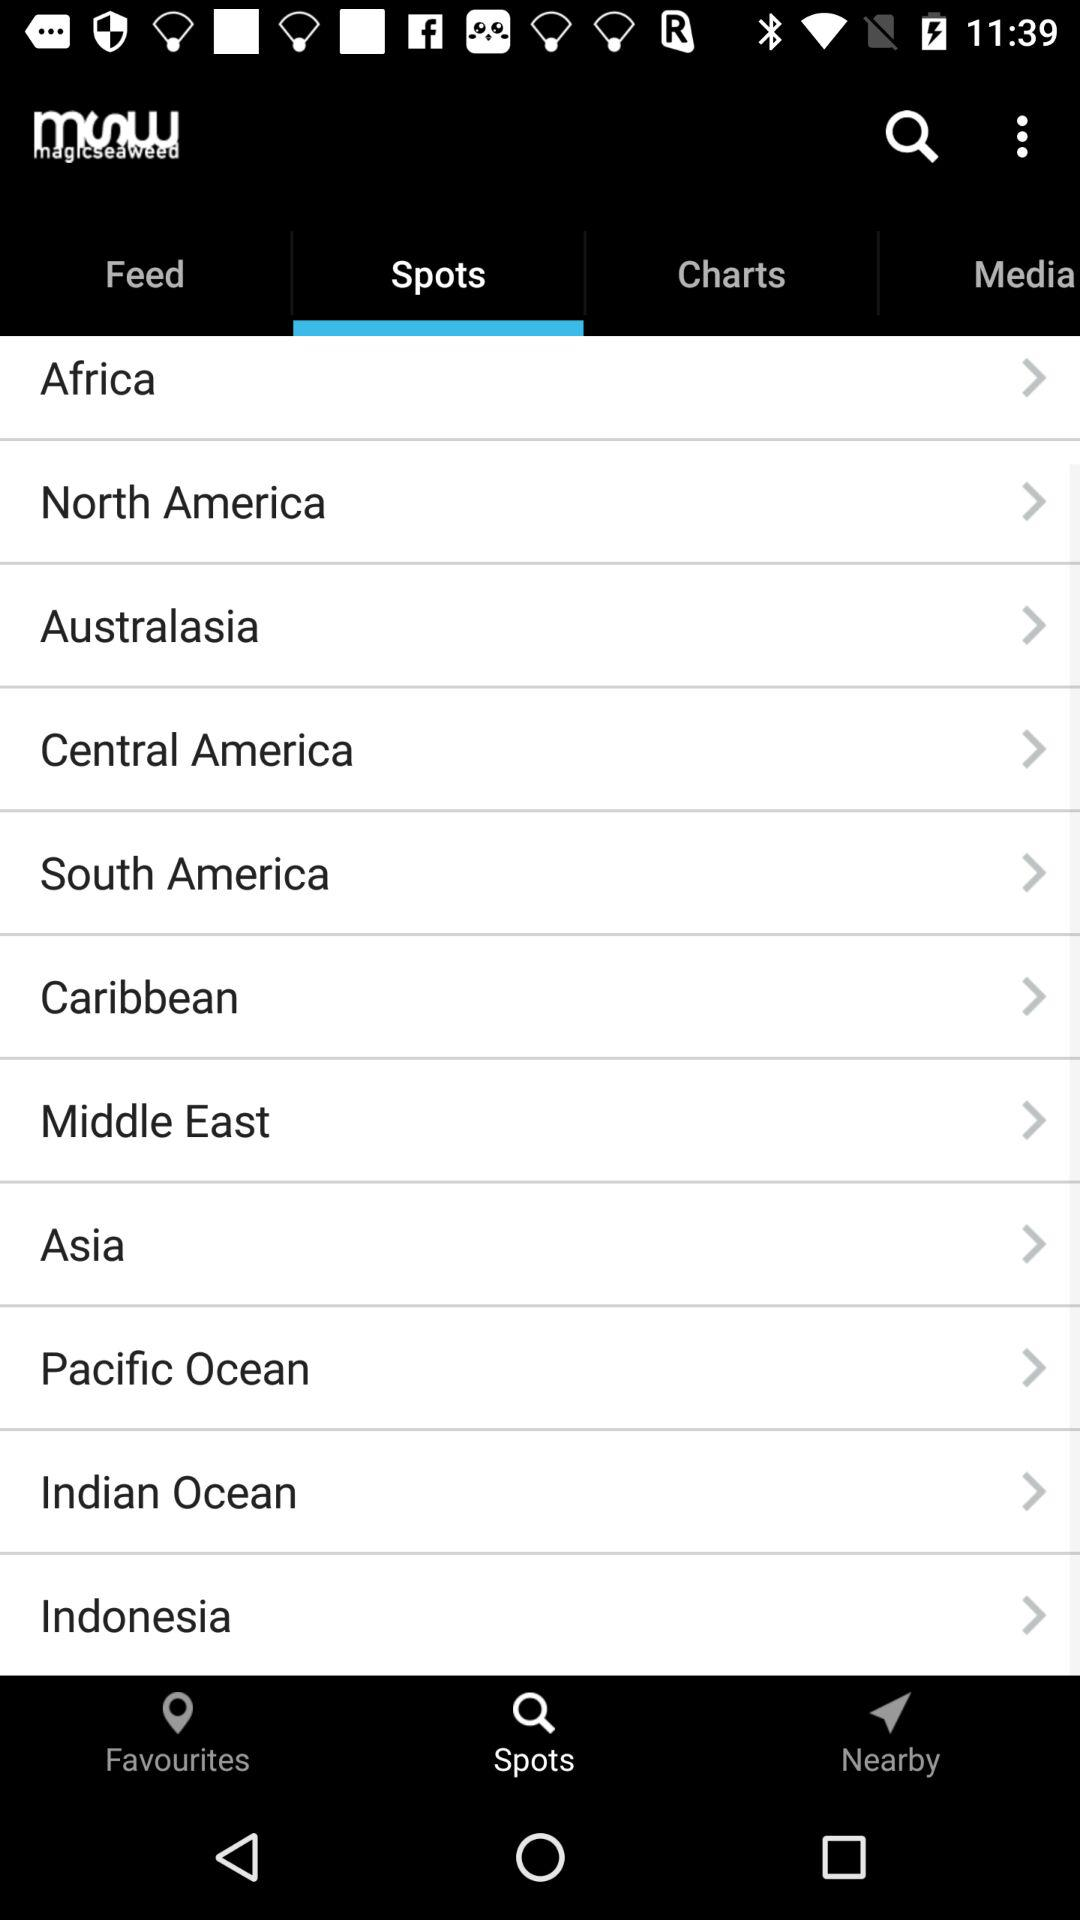Which tab is selected? The selected tab is "Spots". 